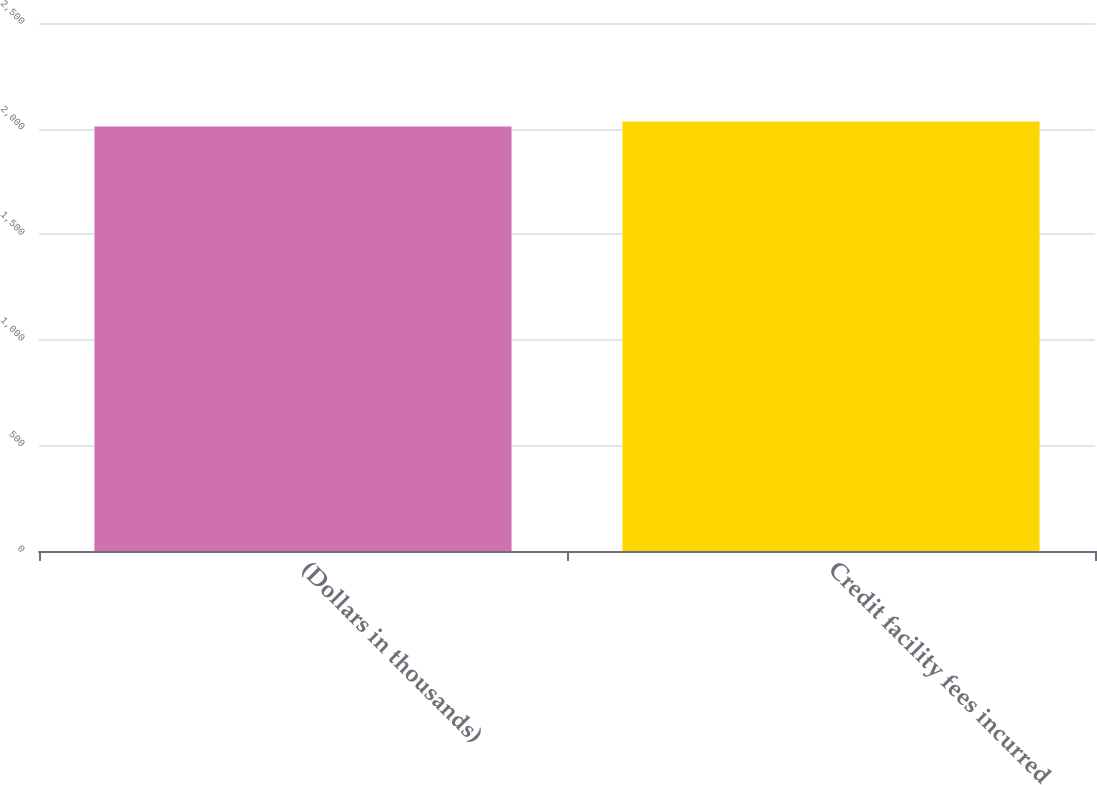Convert chart. <chart><loc_0><loc_0><loc_500><loc_500><bar_chart><fcel>(Dollars in thousands)<fcel>Credit facility fees incurred<nl><fcel>2010<fcel>2034<nl></chart> 